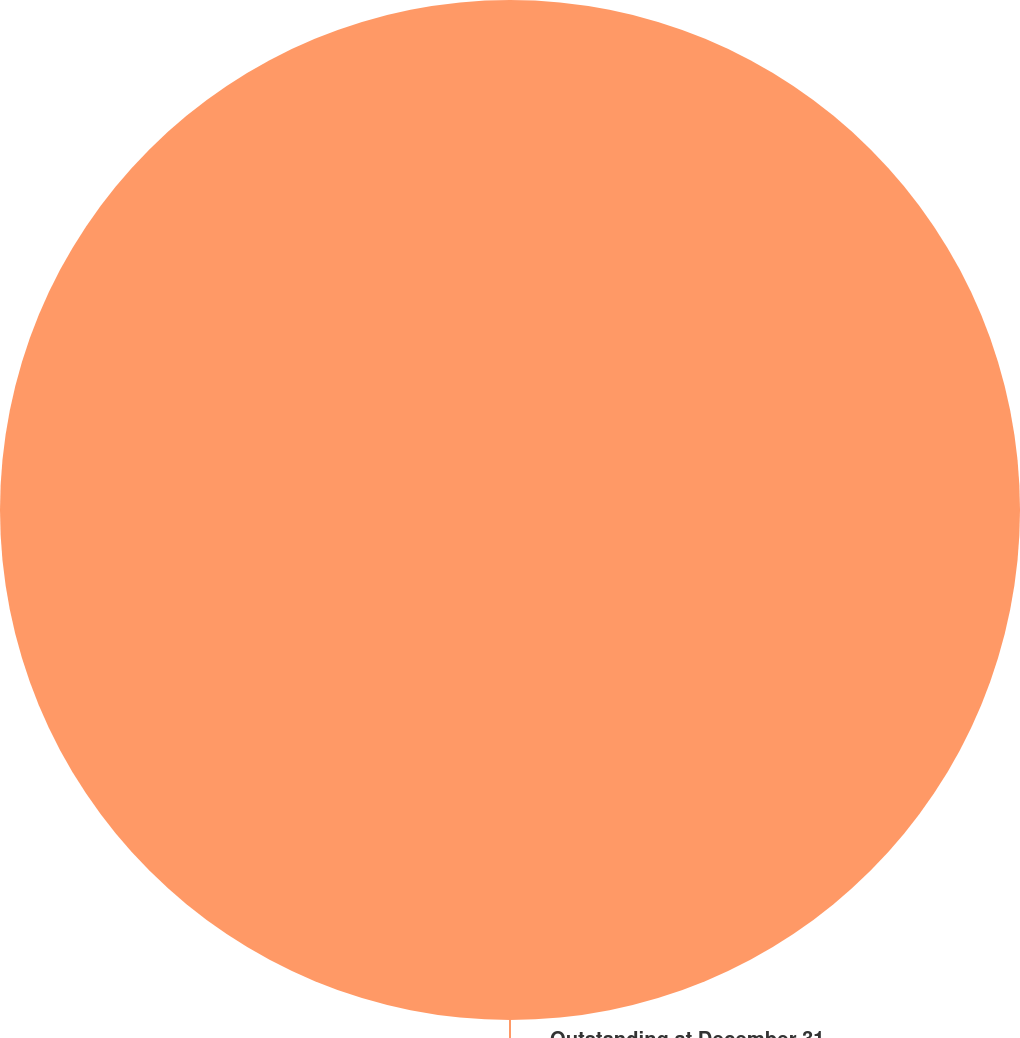Convert chart. <chart><loc_0><loc_0><loc_500><loc_500><pie_chart><fcel>Outstanding at December 31<nl><fcel>100.0%<nl></chart> 